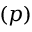Convert formula to latex. <formula><loc_0><loc_0><loc_500><loc_500>( p )</formula> 